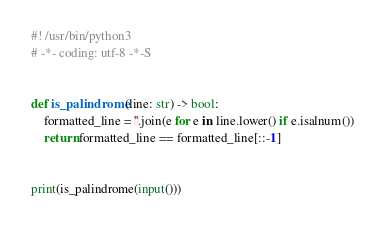Convert code to text. <code><loc_0><loc_0><loc_500><loc_500><_Python_>#! /usr/bin/python3
# -*- coding: utf-8 -*-S


def is_palindrome(line: str) -> bool:
    formatted_line = ''.join(e for e in line.lower() if e.isalnum())
    return formatted_line == formatted_line[::-1]


print(is_palindrome(input()))
</code> 